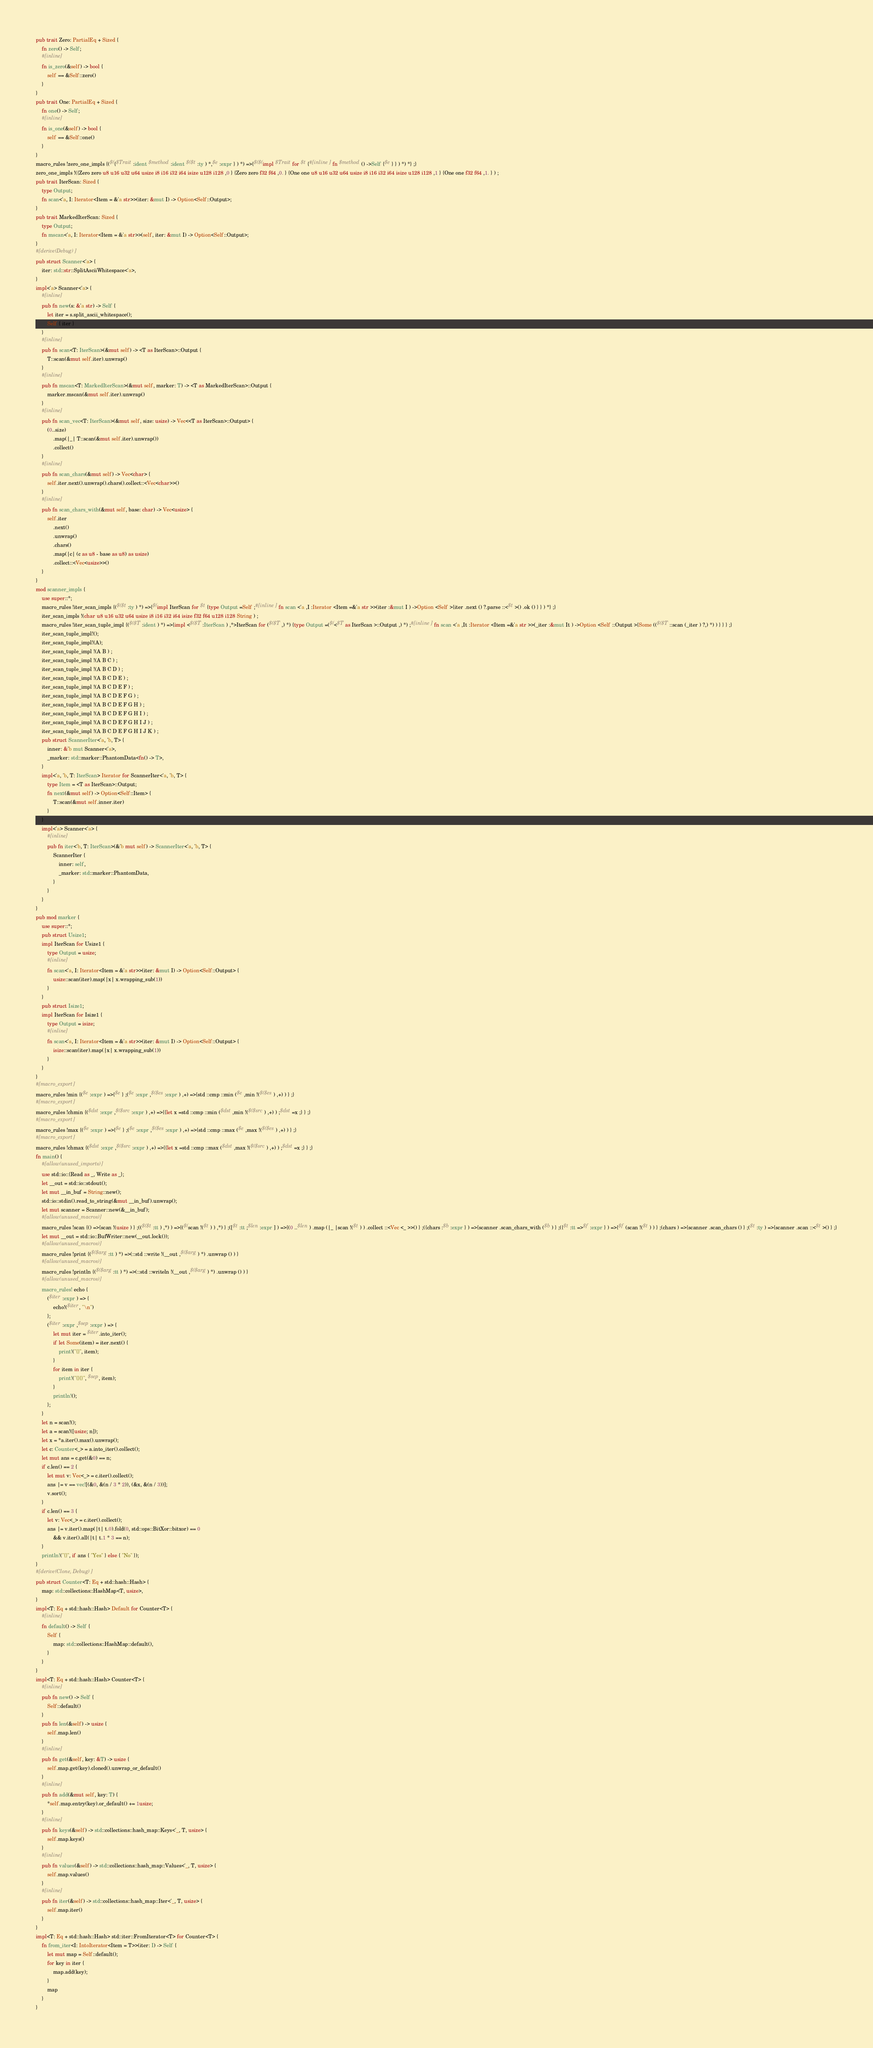Convert code to text. <code><loc_0><loc_0><loc_500><loc_500><_Rust_>pub trait Zero: PartialEq + Sized {
    fn zero() -> Self;
    #[inline]
    fn is_zero(&self) -> bool {
        self == &Self::zero()
    }
}
pub trait One: PartialEq + Sized {
    fn one() -> Self;
    #[inline]
    fn is_one(&self) -> bool {
        self == &Self::one()
    }
}
macro_rules !zero_one_impls {($({$Trait :ident $method :ident $($t :ty ) *,$e :expr } ) *) =>{$($(impl $Trait for $t {#[inline ] fn $method () ->Self {$e } } ) *) *} ;}
zero_one_impls !({Zero zero u8 u16 u32 u64 usize i8 i16 i32 i64 isize u128 i128 ,0 } {Zero zero f32 f64 ,0. } {One one u8 u16 u32 u64 usize i8 i16 i32 i64 isize u128 i128 ,1 } {One one f32 f64 ,1. } ) ;
pub trait IterScan: Sized {
    type Output;
    fn scan<'a, I: Iterator<Item = &'a str>>(iter: &mut I) -> Option<Self::Output>;
}
pub trait MarkedIterScan: Sized {
    type Output;
    fn mscan<'a, I: Iterator<Item = &'a str>>(self, iter: &mut I) -> Option<Self::Output>;
}
#[derive(Debug)]
pub struct Scanner<'a> {
    iter: std::str::SplitAsciiWhitespace<'a>,
}
impl<'a> Scanner<'a> {
    #[inline]
    pub fn new(s: &'a str) -> Self {
        let iter = s.split_ascii_whitespace();
        Self { iter }
    }
    #[inline]
    pub fn scan<T: IterScan>(&mut self) -> <T as IterScan>::Output {
        T::scan(&mut self.iter).unwrap()
    }
    #[inline]
    pub fn mscan<T: MarkedIterScan>(&mut self, marker: T) -> <T as MarkedIterScan>::Output {
        marker.mscan(&mut self.iter).unwrap()
    }
    #[inline]
    pub fn scan_vec<T: IterScan>(&mut self, size: usize) -> Vec<<T as IterScan>::Output> {
        (0..size)
            .map(|_| T::scan(&mut self.iter).unwrap())
            .collect()
    }
    #[inline]
    pub fn scan_chars(&mut self) -> Vec<char> {
        self.iter.next().unwrap().chars().collect::<Vec<char>>()
    }
    #[inline]
    pub fn scan_chars_with(&mut self, base: char) -> Vec<usize> {
        self.iter
            .next()
            .unwrap()
            .chars()
            .map(|c| (c as u8 - base as u8) as usize)
            .collect::<Vec<usize>>()
    }
}
mod scanner_impls {
    use super::*;
    macro_rules !iter_scan_impls {($($t :ty ) *) =>{$(impl IterScan for $t {type Output =Self ;#[inline ] fn scan <'a ,I :Iterator <Item =&'a str >>(iter :&mut I ) ->Option <Self >{iter .next () ?.parse ::<$t >() .ok () } } ) *} ;}
    iter_scan_impls !(char u8 u16 u32 u64 usize i8 i16 i32 i64 isize f32 f64 u128 i128 String ) ;
    macro_rules !iter_scan_tuple_impl {($($T :ident ) *) =>{impl <$($T :IterScan ) ,*>IterScan for ($($T ,) *) {type Output =($(<$T as IterScan >::Output ,) *) ;#[inline ] fn scan <'a ,It :Iterator <Item =&'a str >>(_iter :&mut It ) ->Option <Self ::Output >{Some (($($T ::scan (_iter ) ?,) *) ) } } } ;}
    iter_scan_tuple_impl!();
    iter_scan_tuple_impl!(A);
    iter_scan_tuple_impl !(A B ) ;
    iter_scan_tuple_impl !(A B C ) ;
    iter_scan_tuple_impl !(A B C D ) ;
    iter_scan_tuple_impl !(A B C D E ) ;
    iter_scan_tuple_impl !(A B C D E F ) ;
    iter_scan_tuple_impl !(A B C D E F G ) ;
    iter_scan_tuple_impl !(A B C D E F G H ) ;
    iter_scan_tuple_impl !(A B C D E F G H I ) ;
    iter_scan_tuple_impl !(A B C D E F G H I J ) ;
    iter_scan_tuple_impl !(A B C D E F G H I J K ) ;
    pub struct ScannerIter<'a, 'b, T> {
        inner: &'b mut Scanner<'a>,
        _marker: std::marker::PhantomData<fn() -> T>,
    }
    impl<'a, 'b, T: IterScan> Iterator for ScannerIter<'a, 'b, T> {
        type Item = <T as IterScan>::Output;
        fn next(&mut self) -> Option<Self::Item> {
            T::scan(&mut self.inner.iter)
        }
    }
    impl<'a> Scanner<'a> {
        #[inline]
        pub fn iter<'b, T: IterScan>(&'b mut self) -> ScannerIter<'a, 'b, T> {
            ScannerIter {
                inner: self,
                _marker: std::marker::PhantomData,
            }
        }
    }
}
pub mod marker {
    use super::*;
    pub struct Usize1;
    impl IterScan for Usize1 {
        type Output = usize;
        #[inline]
        fn scan<'a, I: Iterator<Item = &'a str>>(iter: &mut I) -> Option<Self::Output> {
            usize::scan(iter).map(|x| x.wrapping_sub(1))
        }
    }
    pub struct Isize1;
    impl IterScan for Isize1 {
        type Output = isize;
        #[inline]
        fn scan<'a, I: Iterator<Item = &'a str>>(iter: &mut I) -> Option<Self::Output> {
            isize::scan(iter).map(|x| x.wrapping_sub(1))
        }
    }
}
#[macro_export]
macro_rules !min {($e :expr ) =>{$e } ;($e :expr ,$($es :expr ) ,+) =>{std ::cmp ::min ($e ,min !($($es ) ,+) ) } ;}
#[macro_export]
macro_rules !chmin {($dst :expr ,$($src :expr ) ,+) =>{{let x =std ::cmp ::min ($dst ,min !($($src ) ,+) ) ;$dst =x ;} } ;}
#[macro_export]
macro_rules !max {($e :expr ) =>{$e } ;($e :expr ,$($es :expr ) ,+) =>{std ::cmp ::max ($e ,max !($($es ) ,+) ) } ;}
#[macro_export]
macro_rules !chmax {($dst :expr ,$($src :expr ) ,+) =>{{let x =std ::cmp ::max ($dst ,max !($($src ) ,+) ) ;$dst =x ;} } ;}
fn main() {
    #[allow(unused_imports)]
    use std::io::{Read as _, Write as _};
    let __out = std::io::stdout();
    let mut __in_buf = String::new();
    std::io::stdin().read_to_string(&mut __in_buf).unwrap();
    let mut scanner = Scanner::new(&__in_buf);
    #[allow(unused_macros)]
    macro_rules !scan {() =>{scan !(usize ) } ;(($($t :tt ) ,*) ) =>{($(scan !($t ) ) ,*) } ;([$t :tt ;$len :expr ] ) =>{(0 ..$len ) .map (|_ |scan !($t ) ) .collect ::<Vec <_ >>() } ;({chars :$b :expr } ) =>{scanner .scan_chars_with ($b ) } ;({$t :tt =>$f :expr } ) =>{$f (scan !($t ) ) } ;(chars ) =>{scanner .scan_chars () } ;($t :ty ) =>{scanner .scan ::<$t >() } ;}
    let mut __out = std::io::BufWriter::new(__out.lock());
    #[allow(unused_macros)]
    macro_rules !print {($($arg :tt ) *) =>(::std ::write !(__out ,$($arg ) *) .unwrap () ) }
    #[allow(unused_macros)]
    macro_rules !println {($($arg :tt ) *) =>(::std ::writeln !(__out ,$($arg ) *) .unwrap () ) }
    #[allow(unused_macros)]
    macro_rules! echo {
        ($iter :expr ) => {
            echo!($iter, "\n")
        };
        ($iter :expr ,$sep :expr ) => {
            let mut iter = $iter.into_iter();
            if let Some(item) = iter.next() {
                print!("{}", item);
            }
            for item in iter {
                print!("{}{}", $sep, item);
            }
            println!();
        };
    }
    let n = scan!();
    let a = scan!([usize; n]);
    let x = *a.iter().max().unwrap();
    let c: Counter<_> = a.into_iter().collect();
    let mut ans = c.get(&0) == n;
    if c.len() == 2 {
        let mut v: Vec<_> = c.iter().collect();
        ans |= v == vec![(&0, &(n / 3 * 2)), (&x, &(n / 3))];
        v.sort();
    }
    if c.len() == 3 {
        let v: Vec<_> = c.iter().collect();
        ans |= v.iter().map(|t| t.0).fold(0, std::ops::BitXor::bitxor) == 0
            && v.iter().all(|t| t.1 * 3 == n);
    }
    println!("{}", if ans { "Yes" } else { "No" });
}
#[derive(Clone, Debug)]
pub struct Counter<T: Eq + std::hash::Hash> {
    map: std::collections::HashMap<T, usize>,
}
impl<T: Eq + std::hash::Hash> Default for Counter<T> {
    #[inline]
    fn default() -> Self {
        Self {
            map: std::collections::HashMap::default(),
        }
    }
}
impl<T: Eq + std::hash::Hash> Counter<T> {
    #[inline]
    pub fn new() -> Self {
        Self::default()
    }
    pub fn len(&self) -> usize {
        self.map.len()
    }
    #[inline]
    pub fn get(&self, key: &T) -> usize {
        self.map.get(key).cloned().unwrap_or_default()
    }
    #[inline]
    pub fn add(&mut self, key: T) {
        *self.map.entry(key).or_default() += 1usize;
    }
    #[inline]
    pub fn keys(&self) -> std::collections::hash_map::Keys<'_, T, usize> {
        self.map.keys()
    }
    #[inline]
    pub fn values(&self) -> std::collections::hash_map::Values<'_, T, usize> {
        self.map.values()
    }
    #[inline]
    pub fn iter(&self) -> std::collections::hash_map::Iter<'_, T, usize> {
        self.map.iter()
    }
}
impl<T: Eq + std::hash::Hash> std::iter::FromIterator<T> for Counter<T> {
    fn from_iter<I: IntoIterator<Item = T>>(iter: I) -> Self {
        let mut map = Self::default();
        for key in iter {
            map.add(key);
        }
        map
    }
}</code> 